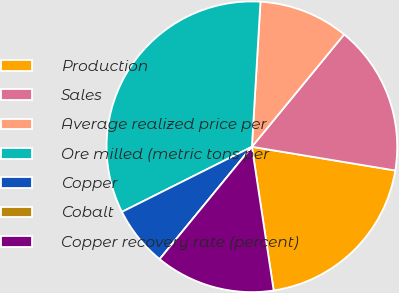Convert chart to OTSL. <chart><loc_0><loc_0><loc_500><loc_500><pie_chart><fcel>Production<fcel>Sales<fcel>Average realized price per<fcel>Ore milled (metric tons per<fcel>Copper<fcel>Cobalt<fcel>Copper recovery rate (percent)<nl><fcel>20.0%<fcel>16.67%<fcel>10.0%<fcel>33.33%<fcel>6.67%<fcel>0.0%<fcel>13.33%<nl></chart> 